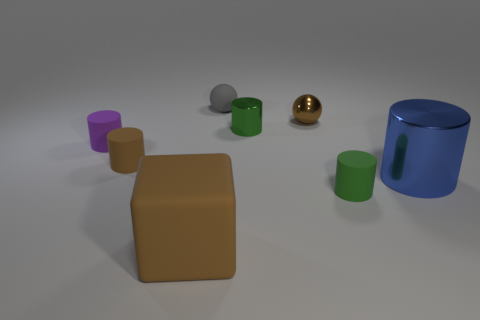Subtract all green cylinders. How many were subtracted if there are1green cylinders left? 1 Subtract all gray cylinders. Subtract all blue blocks. How many cylinders are left? 5 Add 1 small spheres. How many objects exist? 9 Subtract all blocks. How many objects are left? 7 Subtract 0 yellow cylinders. How many objects are left? 8 Subtract all tiny shiny balls. Subtract all small green cylinders. How many objects are left? 5 Add 5 brown things. How many brown things are left? 8 Add 8 big blue cylinders. How many big blue cylinders exist? 9 